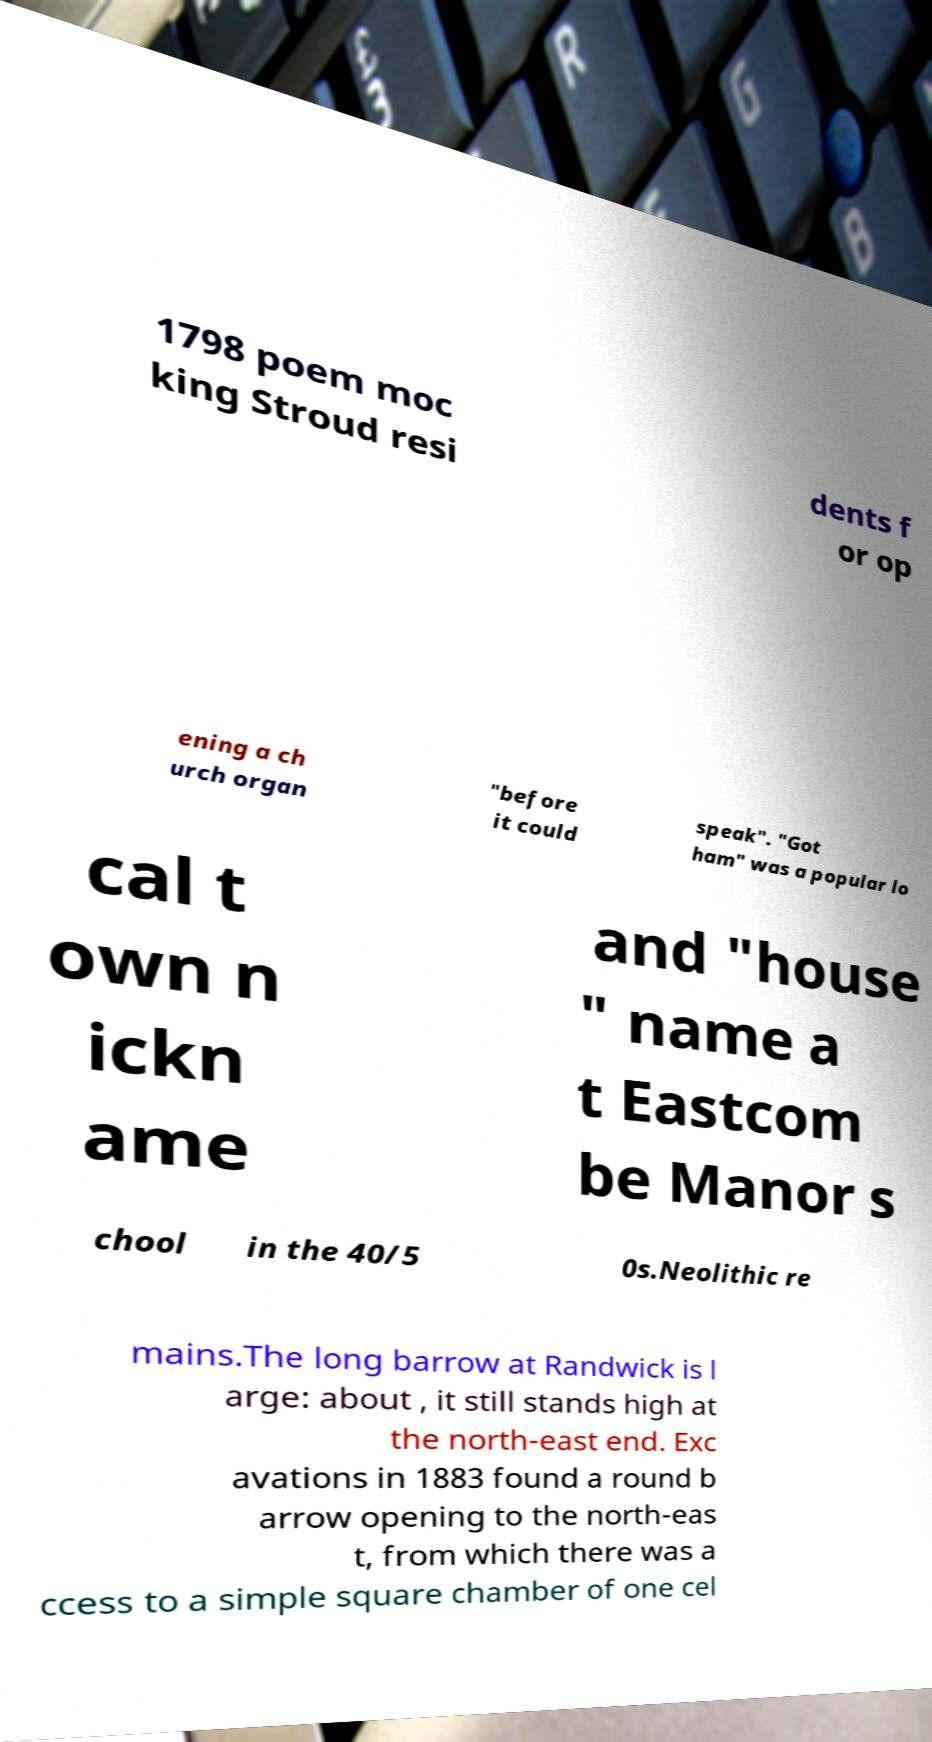Could you assist in decoding the text presented in this image and type it out clearly? 1798 poem moc king Stroud resi dents f or op ening a ch urch organ "before it could speak". "Got ham" was a popular lo cal t own n ickn ame and "house " name a t Eastcom be Manor s chool in the 40/5 0s.Neolithic re mains.The long barrow at Randwick is l arge: about , it still stands high at the north-east end. Exc avations in 1883 found a round b arrow opening to the north-eas t, from which there was a ccess to a simple square chamber of one cel 